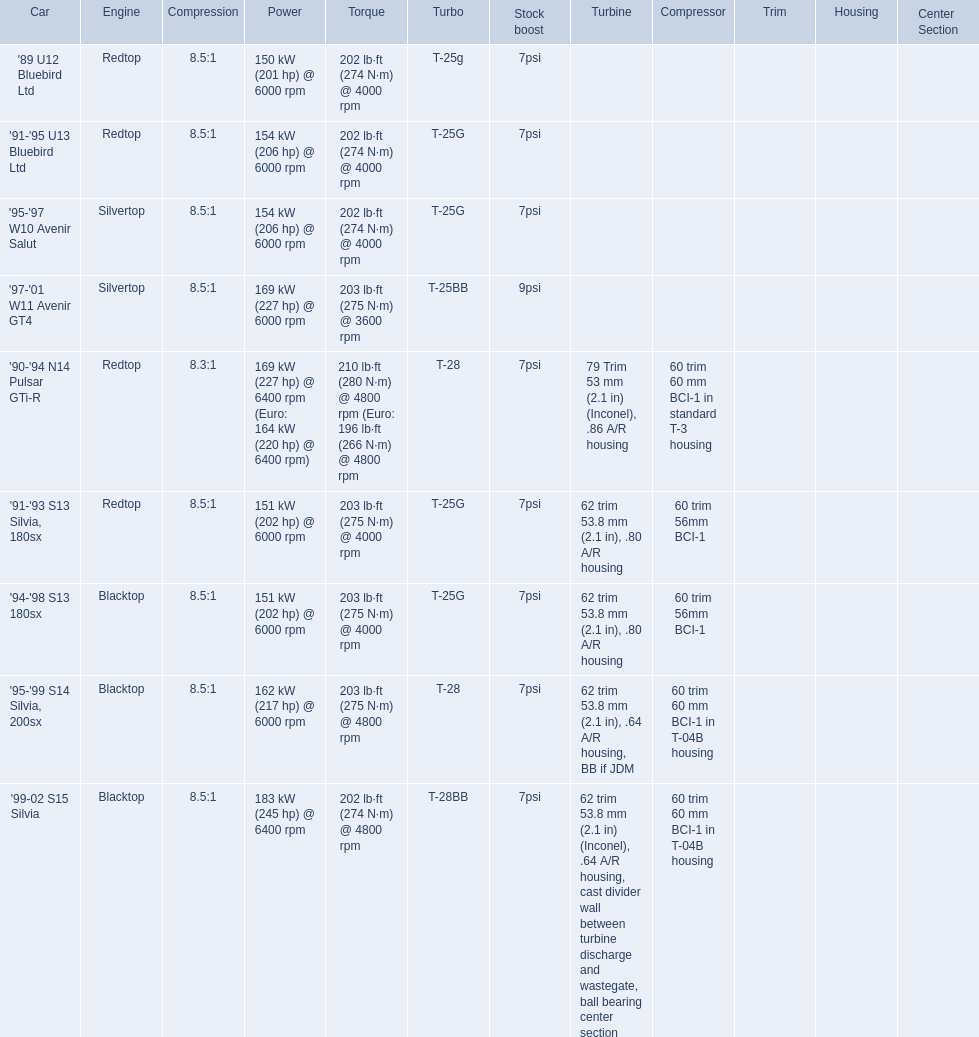What are all of the nissan cars? '89 U12 Bluebird Ltd, '91-'95 U13 Bluebird Ltd, '95-'97 W10 Avenir Salut, '97-'01 W11 Avenir GT4, '90-'94 N14 Pulsar GTi-R, '91-'93 S13 Silvia, 180sx, '94-'98 S13 180sx, '95-'99 S14 Silvia, 200sx, '99-02 S15 Silvia. Of these cars, which one is a '90-'94 n14 pulsar gti-r? '90-'94 N14 Pulsar GTi-R. What is the compression of this car? 8.3:1. 